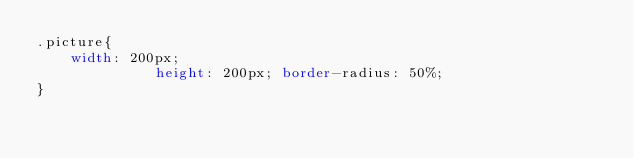<code> <loc_0><loc_0><loc_500><loc_500><_CSS_>.picture{
    width: 200px;
              height: 200px; border-radius: 50%;
}</code> 